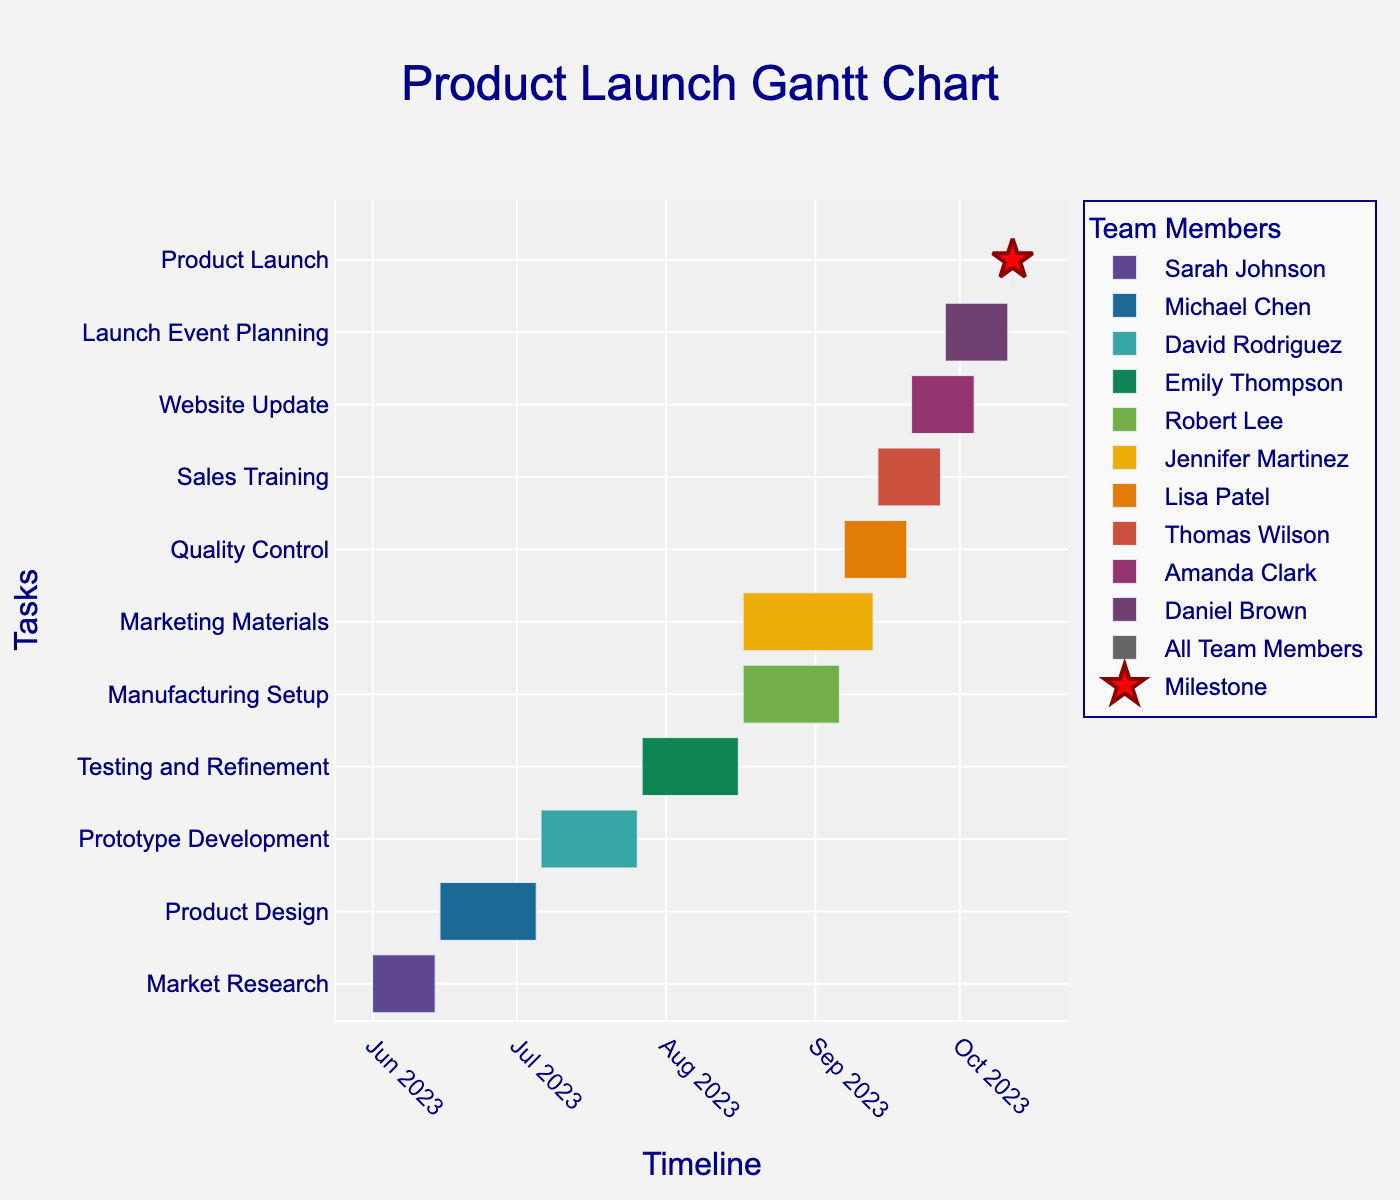What is the title of the chart? The title of the chart is provided at the top of the visual.
Answer: Product Launch Gantt Chart Who is responsible for the Product Design task? The chart uses different colors to indicate team members responsible for each task. The Product Design task is labeled with Michael Chen's name next to it.
Answer: Michael Chen How many days does the Testing and Refinement task take? The duration of each task is shown in the customdata when you hover over the task.
Answer: 21 Which task has the shortest duration, and how long is it? By looking at the bar lengths and durations, the Product Launch task has the shortest duration of 1 day.
Answer: Product Launch, 1 day Between which dates is the Market Research task scheduled? The start and end dates of each task are labeled along the timeline. Market Research is scheduled from June 1, 2023, to June 14, 2023.
Answer: June 1, 2023 - June 14, 2023 How many tasks overlap with the Manufacturing Setup? Hovering over the Manufacturing Setup task shows its duration. Overlapping tasks are those that share common dates. The tasks overlapping with Manufacturing Setup are Marketing Materials (Aug 17 - Sep 13).
Answer: 1 Which tasks are assigned to Sarah Johnson, and what are their durations? Sarah Johnson's color coding shows that she is responsible for Market Research. Hovering over the task reveals its duration, 14 days.
Answer: Market Research, 14 days What is the total duration of all tasks combined? Sum up the durations of each task from the chart. The values are: 14 + 21 + 21 + 21 + 21 + 14 + 28 + 14 + 14 + 14 + 1 = 183 days
Answer: 183 days Which tasks are scheduled to start in July? By looking at the start dates in July, the tasks are Product Design (ends July 5), Prototype Development (starts July 6), and Testing and Refinement (starts July 27).
Answer: Prototype Development, Testing and Refinement How many tasks are each team member responsible for? Count the number of distinct tasks assigned to each team member by observing the colors and hover information.
Answer: Sarah Johnson: 1, Michael Chen: 1, David Rodriguez: 1, Emily Thompson: 1, Robert Lee: 1, Lisa Patel: 1, Jennifer Martinez: 1, Thomas Wilson: 1, Amanda Clark: 1, Daniel Brown: 1, All Team Members: 1 